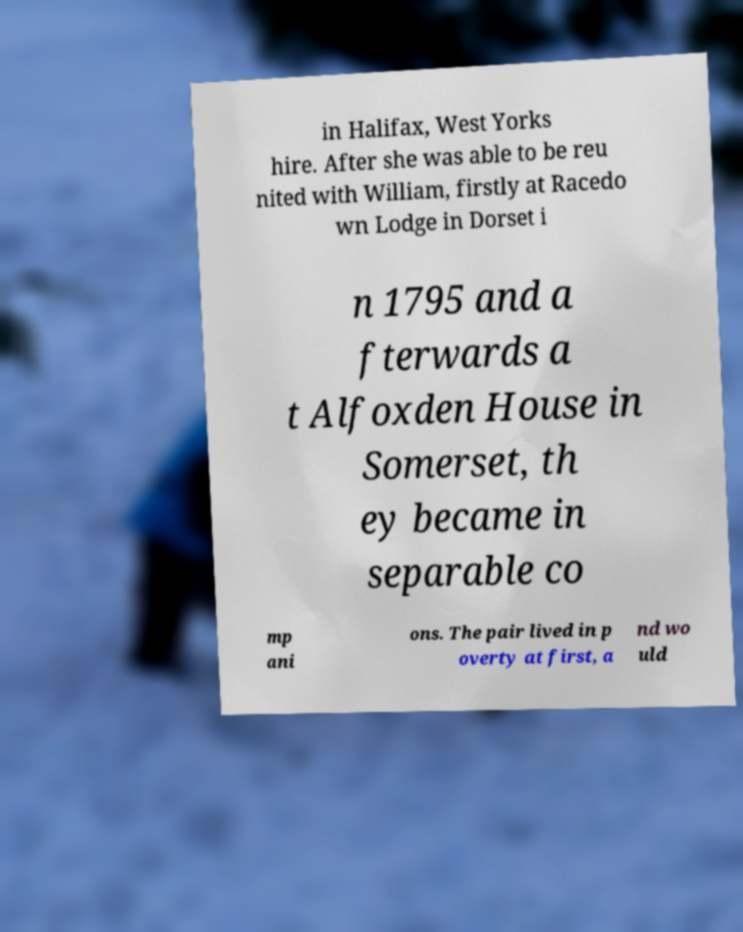Can you read and provide the text displayed in the image?This photo seems to have some interesting text. Can you extract and type it out for me? in Halifax, West Yorks hire. After she was able to be reu nited with William, firstly at Racedo wn Lodge in Dorset i n 1795 and a fterwards a t Alfoxden House in Somerset, th ey became in separable co mp ani ons. The pair lived in p overty at first, a nd wo uld 